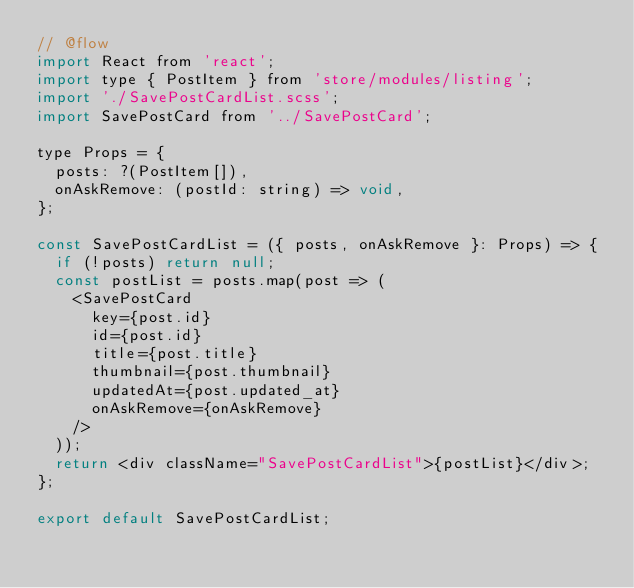<code> <loc_0><loc_0><loc_500><loc_500><_JavaScript_>// @flow
import React from 'react';
import type { PostItem } from 'store/modules/listing';
import './SavePostCardList.scss';
import SavePostCard from '../SavePostCard';

type Props = {
  posts: ?(PostItem[]),
  onAskRemove: (postId: string) => void,
};

const SavePostCardList = ({ posts, onAskRemove }: Props) => {
  if (!posts) return null;
  const postList = posts.map(post => (
    <SavePostCard
      key={post.id}
      id={post.id}
      title={post.title}
      thumbnail={post.thumbnail}
      updatedAt={post.updated_at}
      onAskRemove={onAskRemove}
    />
  ));
  return <div className="SavePostCardList">{postList}</div>;
};

export default SavePostCardList;
</code> 